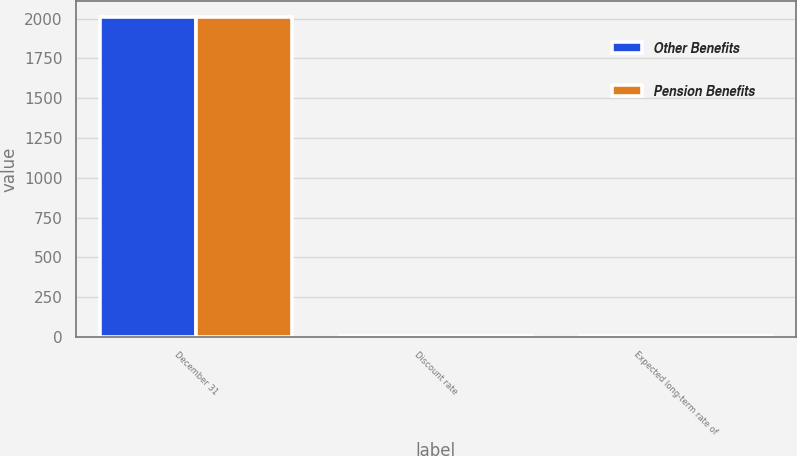<chart> <loc_0><loc_0><loc_500><loc_500><stacked_bar_chart><ecel><fcel>December 31<fcel>Discount rate<fcel>Expected long-term rate of<nl><fcel>Other Benefits<fcel>2011<fcel>5.5<fcel>8.25<nl><fcel>Pension Benefits<fcel>2011<fcel>5.25<fcel>4.75<nl></chart> 